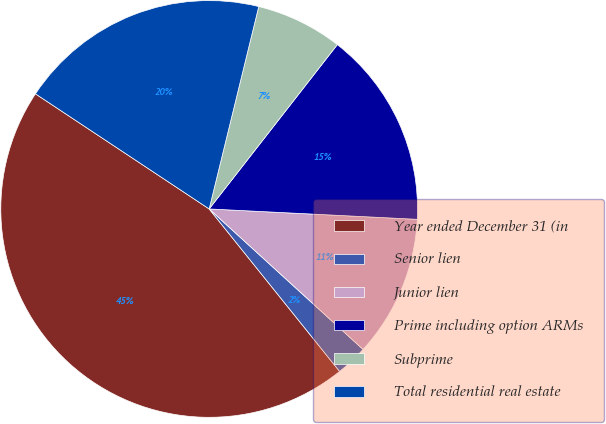Convert chart to OTSL. <chart><loc_0><loc_0><loc_500><loc_500><pie_chart><fcel>Year ended December 31 (in<fcel>Senior lien<fcel>Junior lien<fcel>Prime including option ARMs<fcel>Subprime<fcel>Total residential real estate<nl><fcel>45.08%<fcel>2.46%<fcel>10.98%<fcel>15.25%<fcel>6.72%<fcel>19.51%<nl></chart> 